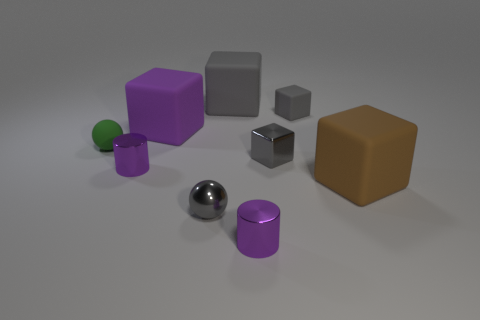Is the color of the tiny metal ball the same as the tiny cube in front of the tiny green sphere?
Give a very brief answer. Yes. The green rubber thing is what size?
Your answer should be compact. Small. How many small rubber spheres are in front of the small purple object that is in front of the gray metallic sphere?
Provide a short and direct response. 0. What is the shape of the small object that is behind the gray metallic cube and left of the small gray matte object?
Make the answer very short. Sphere. How many other big blocks are the same color as the metallic block?
Your response must be concise. 1. Is there a small gray metallic cube that is behind the big block that is on the right side of the tiny thing that is behind the matte sphere?
Your answer should be compact. Yes. There is a rubber cube that is left of the tiny gray rubber cube and right of the gray shiny sphere; how big is it?
Make the answer very short. Large. How many small blocks have the same material as the small gray sphere?
Your answer should be very brief. 1. How many balls are brown objects or purple metallic objects?
Provide a short and direct response. 0. There is a purple cylinder that is in front of the tiny purple metallic object that is behind the gray shiny thing to the left of the big gray rubber cube; what is its size?
Offer a very short reply. Small. 